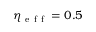Convert formula to latex. <formula><loc_0><loc_0><loc_500><loc_500>\eta _ { e f f } = 0 . 5</formula> 